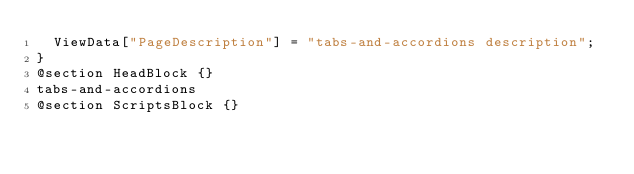<code> <loc_0><loc_0><loc_500><loc_500><_C#_>	ViewData["PageDescription"] = "tabs-and-accordions description";
}
@section HeadBlock {}
tabs-and-accordions
@section ScriptsBlock {}
</code> 